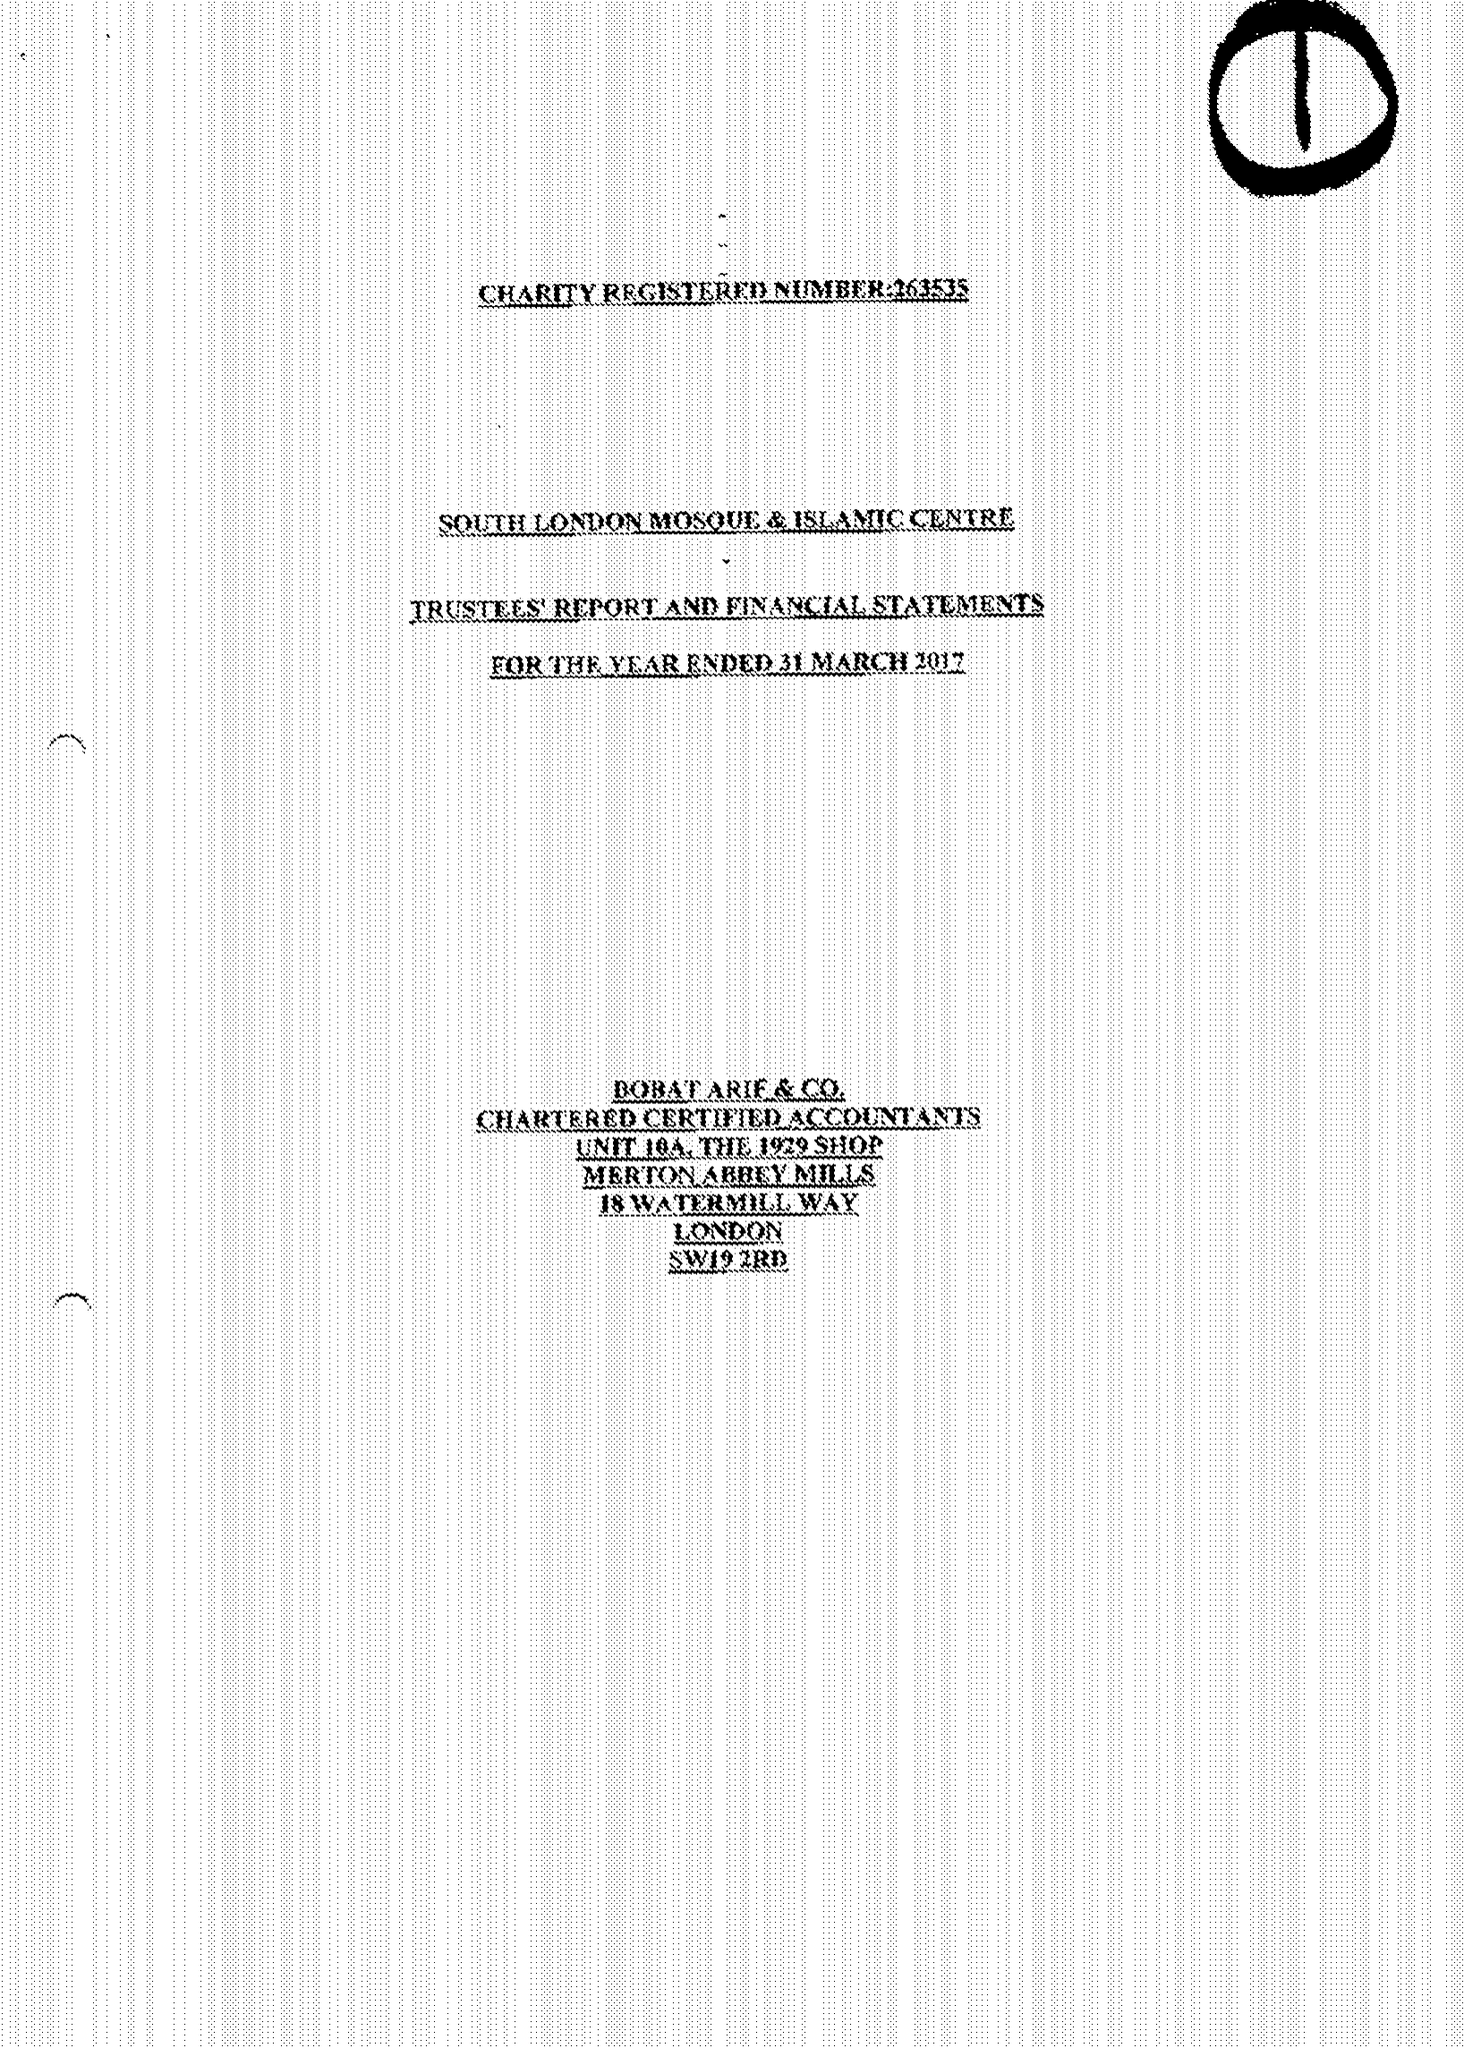What is the value for the charity_name?
Answer the question using a single word or phrase. South London Mosque and Islamic Centre 